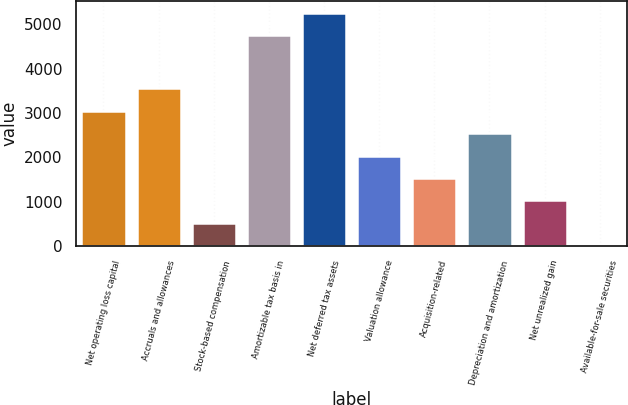Convert chart to OTSL. <chart><loc_0><loc_0><loc_500><loc_500><bar_chart><fcel>Net operating loss capital<fcel>Accruals and allowances<fcel>Stock-based compensation<fcel>Amortizable tax basis in<fcel>Net deferred tax assets<fcel>Valuation allowance<fcel>Acquisition-related<fcel>Depreciation and amortization<fcel>Net unrealized gain<fcel>Available-for-sale securities<nl><fcel>3055.8<fcel>3562.6<fcel>521.8<fcel>4757<fcel>5263.8<fcel>2042.2<fcel>1535.4<fcel>2549<fcel>1028.6<fcel>15<nl></chart> 